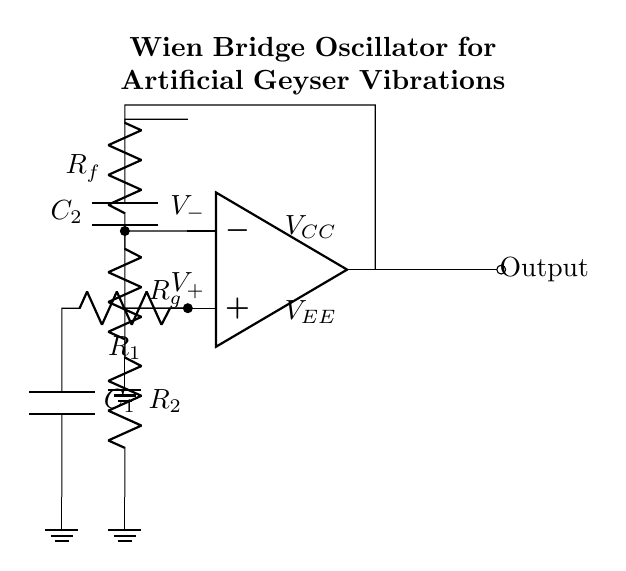What type of circuit is depicted? This circuit is a Wien Bridge Oscillator, which is specifically designed for generating sinusoidal waveforms. It employs a combination of resistors and capacitors to produce oscillations.
Answer: Wien Bridge Oscillator What components are used in the feedback network? The feedback network in the circuit consists of two resistors labeled as R_f and R_g. They connect the output of the operational amplifier back to its inverting input.
Answer: R_f and R_g What is the purpose of the capacitors in this circuit? The capacitors, C_1 and C_2, are used to set the frequency of oscillation in combination with the resistors. In a Wien Bridge Oscillator, they play a critical role in determining the oscillation frequency through the capacitive reactance they provide.
Answer: Frequency setting What happens if R_f is greater than R_g? If R_f is greater than R_g, the feedback to the inverting input becomes stronger, potentially leading to instability or sustained oscillation. The output may increase until it saturates, leading to a distortion of the waveform generated.
Answer: Output saturation How are the resistors arranged in this circuit? The resistors, R_1 and R_2, are arranged in a specific configuration that helps to balance the bridge circuit. They contribute to the feedback loop, helping to stabilize the oscillator performance. This arrangement is key to maintaining the oscillation amplitude.
Answer: Balanced bridge configuration What type of output does this oscillator generate? The output generated by the Wien Bridge Oscillator is a sinusoidal waveform that varies periodically over time. This wave shape is ideal for simulating natural phenomena, like the vibrations of geysers, in an artificial setting.
Answer: Sinusoidal waveform 